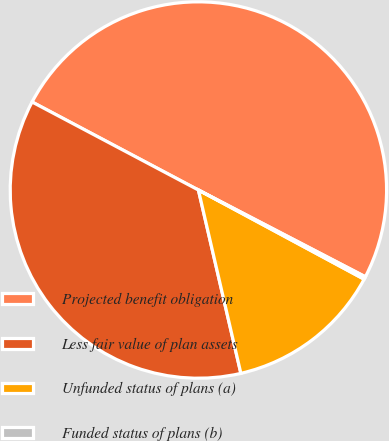Convert chart. <chart><loc_0><loc_0><loc_500><loc_500><pie_chart><fcel>Projected benefit obligation<fcel>Less fair value of plan assets<fcel>Unfunded status of plans (a)<fcel>Funded status of plans (b)<nl><fcel>49.88%<fcel>36.37%<fcel>13.52%<fcel>0.23%<nl></chart> 